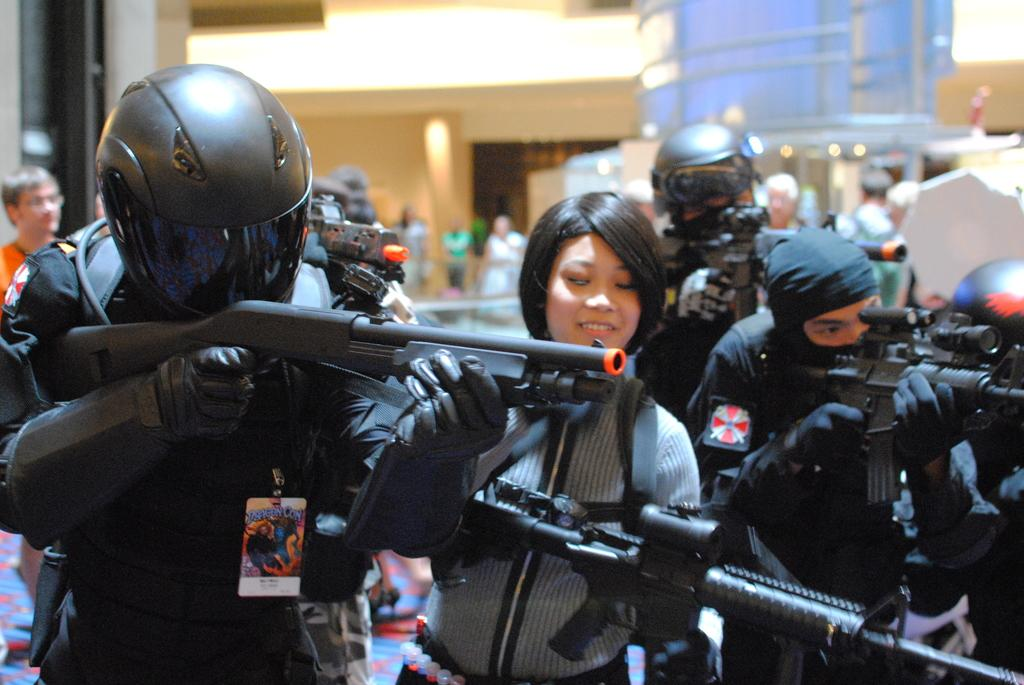What is the main subject of the image? The main subject of the image is the persons in the center. What are the persons holding in their hands? The persons are holding guns in their hands. What can be seen in the background of the image? There are buildings and lights in the background of the image. What type of underwear is visible on the persons in the image? There is no underwear visible on the persons in the image. What material is the canvas used for the image? The image is not a painting or drawing on canvas; it is a photograph or digital image. 